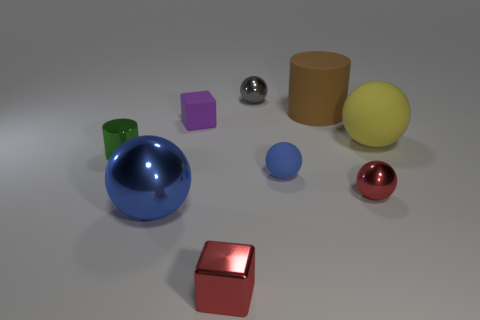Subtract all blue spheres. How many were subtracted if there are1blue spheres left? 1 Subtract all red balls. How many balls are left? 4 Subtract all tiny matte spheres. How many spheres are left? 4 Subtract all brown spheres. Subtract all gray cubes. How many spheres are left? 5 Add 1 large matte spheres. How many objects exist? 10 Subtract all cylinders. How many objects are left? 7 Add 4 green cylinders. How many green cylinders exist? 5 Subtract 1 gray balls. How many objects are left? 8 Subtract all blue matte spheres. Subtract all large rubber spheres. How many objects are left? 7 Add 5 tiny metallic cylinders. How many tiny metallic cylinders are left? 6 